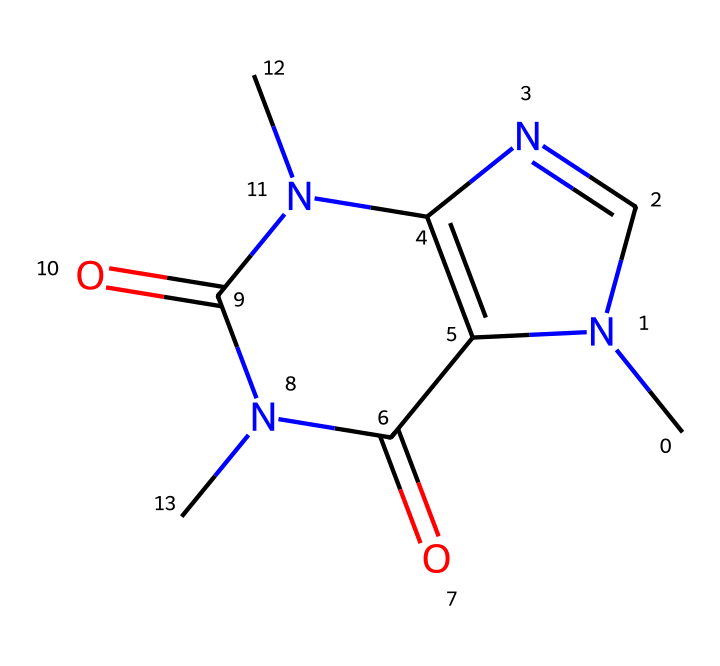What is the molecular formula of caffeine? By analyzing the SMILES representation, we can identify the individual atoms: there are 8 carbon atoms, 10 hydrogen atoms, 4 nitrogen atoms, and 2 oxygen atoms. Therefore, the molecular formula combines these counts.
Answer: C8H10N4O2 How many nitrogen atoms are present in caffeine? By counting the nitrogen symbols (N) in the SMILES structure, we find that there are 4 nitrogen atoms.
Answer: 4 What type of functional groups are present in caffeine? The SMILES representation shows carbonyl (C=O) groups and nitrogen-containing groups, indicating that it contains amide and imine functional groups, characteristic of many alkaloids.
Answer: amide, imine What is the total number of rings in the caffeine structure? By inspecting the SMILES, caffeine contains two interconnected rings formed by the cyclic structures in its central portions.
Answer: 2 Is caffeine a saturated or unsaturated compound? The presence of double bonds (indicated by "=" in the SMILES) implies that caffeine is unsaturated since some carbon atoms do not have the maximum number of hydrogen atoms attached.
Answer: unsaturated What class of compounds does caffeine belong to? Since caffeine contains nitrogen atoms as part of its structure and displays the characteristics typical of these substances, it is classified as an alkaloid.
Answer: alkaloid 